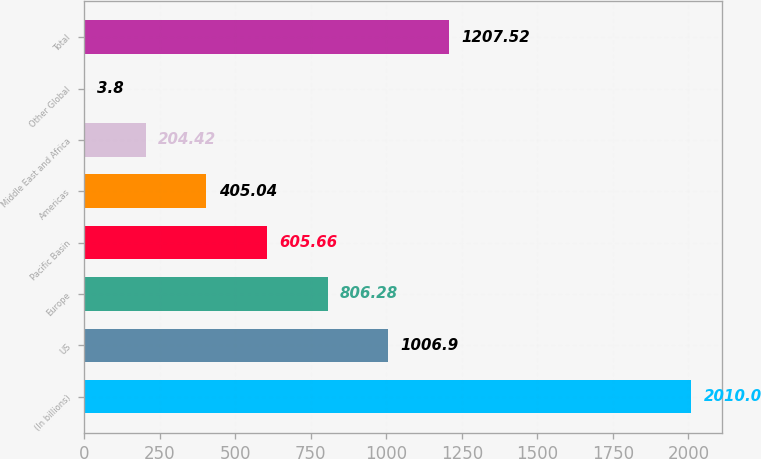Convert chart to OTSL. <chart><loc_0><loc_0><loc_500><loc_500><bar_chart><fcel>(In billions)<fcel>US<fcel>Europe<fcel>Pacific Basin<fcel>Americas<fcel>Middle East and Africa<fcel>Other Global<fcel>Total<nl><fcel>2010<fcel>1006.9<fcel>806.28<fcel>605.66<fcel>405.04<fcel>204.42<fcel>3.8<fcel>1207.52<nl></chart> 